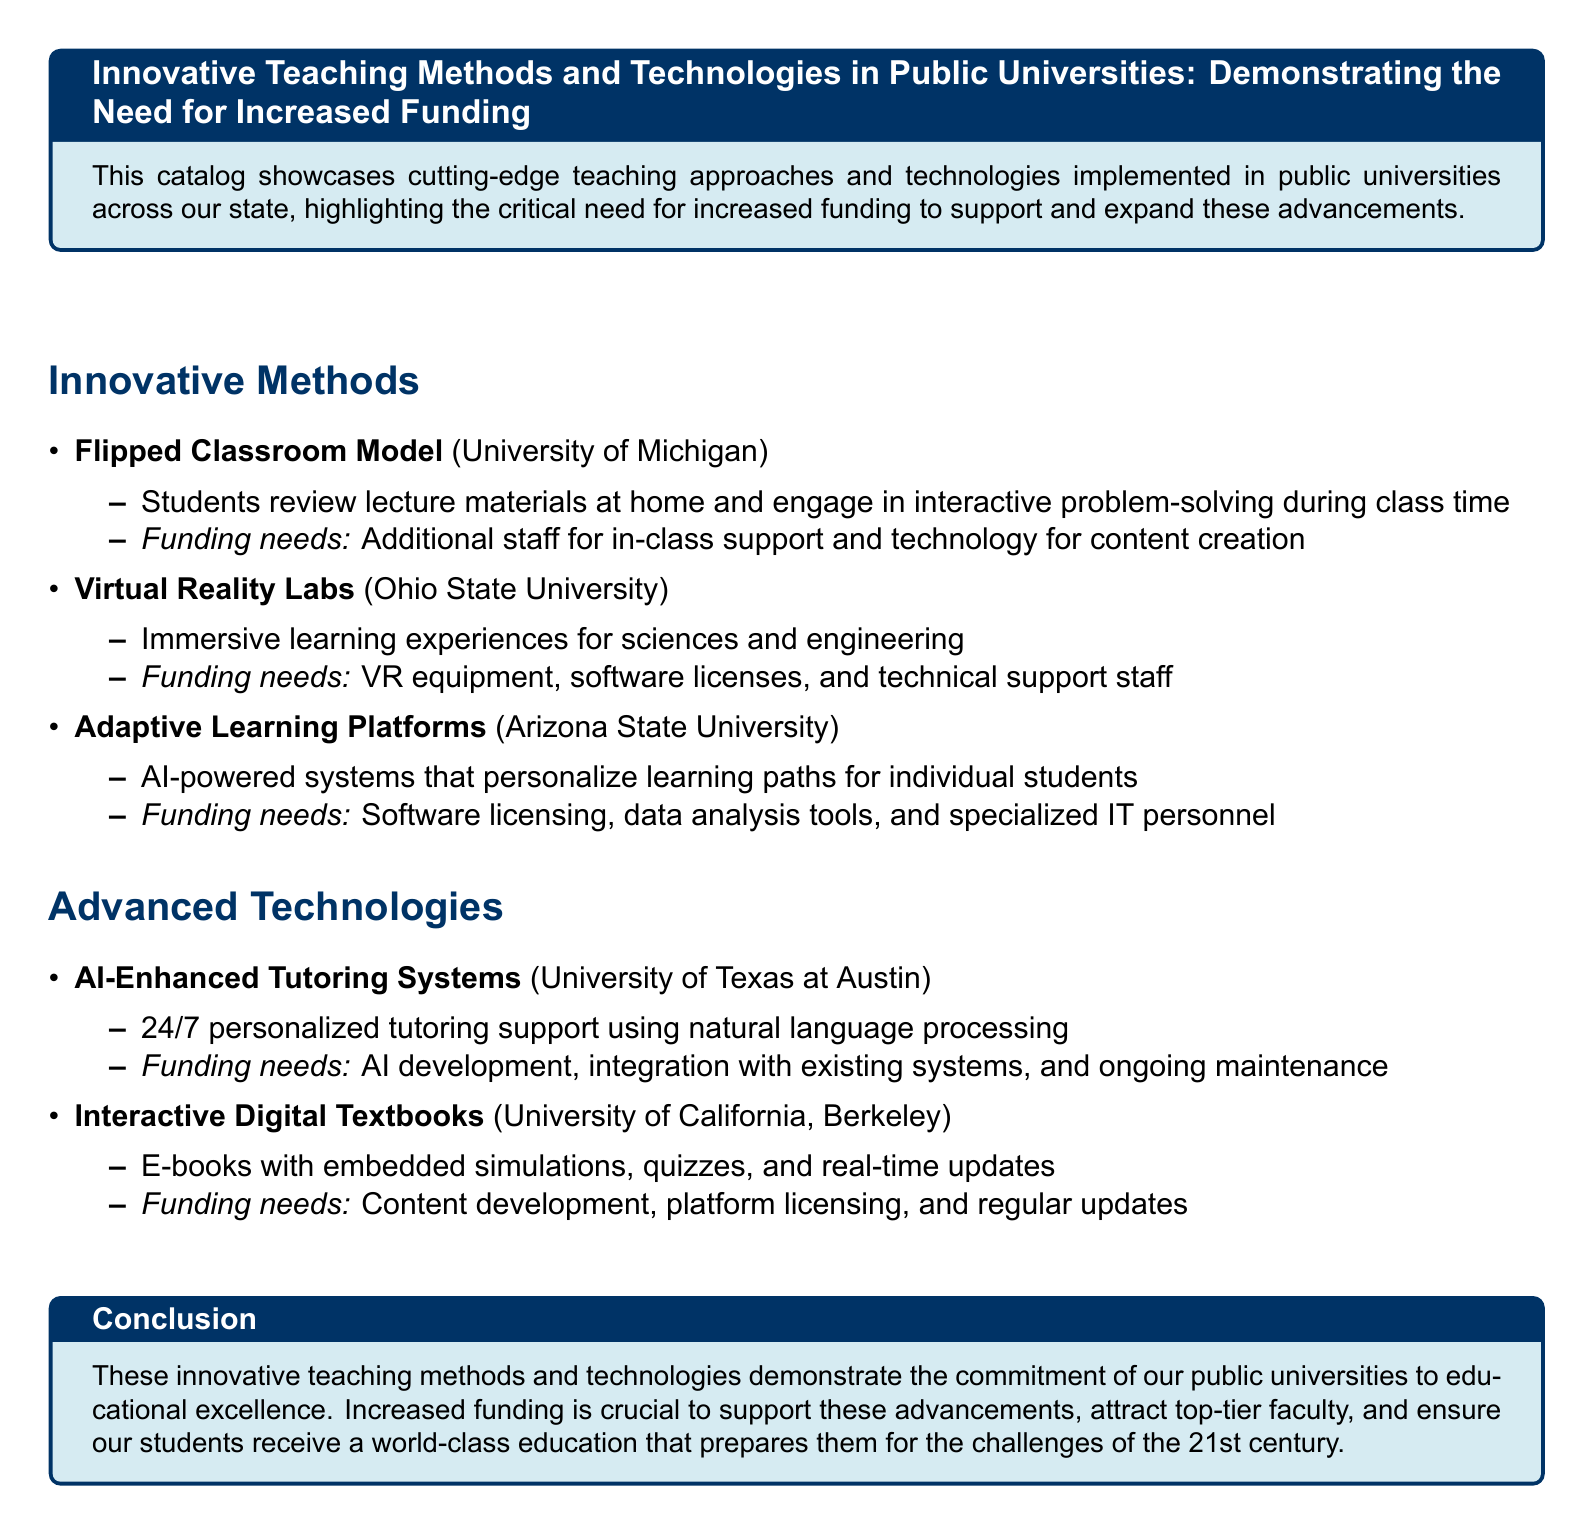What teaching model is used at the University of Michigan? The document states that the University of Michigan implements the Flipped Classroom Model, where students review materials at home and engage in problem-solving in class.
Answer: Flipped Classroom Model What type of learning experience do the Virtual Reality Labs provide? The Virtual Reality Labs at Ohio State University offer immersive learning experiences for sciences and engineering.
Answer: Immersive learning experiences Which university uses Adaptive Learning Platforms? The document mentions Arizona State University as the institution implementing Adaptive Learning Platforms.
Answer: Arizona State University What technology is used for personalized tutoring at the University of Texas at Austin? AI-Enhanced Tutoring Systems are highlighted in the document for providing 24/7 tutoring support using natural language processing.
Answer: AI-Enhanced Tutoring Systems What is one funding need for the Interactive Digital Textbooks at UC Berkeley? The document outlines that one funding need for Interactive Digital Textbooks is content development.
Answer: Content development How do Adaptive Learning Platforms personalize learning? The document explains that Adaptive Learning Platforms use AI-powered systems to personalize learning paths for individual students.
Answer: AI-powered systems What is the common theme of the funding needs mentioned for the innovative methods? The document indicates that the common theme of the funding needs is related to technology and support personnel necessary to implement these methods effectively.
Answer: Technology and support personnel What is the significance of the innovations listed in the catalog? The document emphasizes that these innovations demonstrate the commitment of public universities to educational excellence and the need for increased funding.
Answer: Commitment to educational excellence What does the conclusion emphasize about increased funding? The conclusion highlights that increased funding is crucial to support advancements and attract top-tier faculty for world-class education.
Answer: Crucial to support advancements 